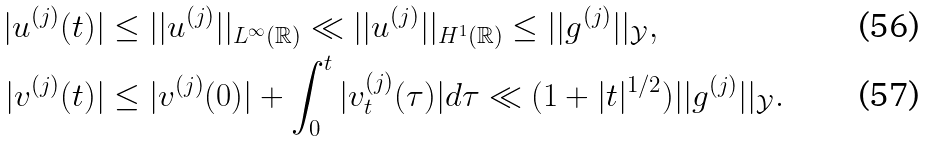Convert formula to latex. <formula><loc_0><loc_0><loc_500><loc_500>| u ^ { ( j ) } ( t ) | & \leq | | u ^ { ( j ) } | | _ { L ^ { \infty } ( \mathbb { R } ) } \ll | | u ^ { ( j ) } | | _ { H ^ { 1 } ( \mathbb { R } ) } \leq | | g ^ { ( j ) } | | _ { \mathcal { Y } } , \\ | v ^ { ( j ) } ( t ) | & \leq | v ^ { ( j ) } ( 0 ) | + \int _ { 0 } ^ { t } | v ^ { ( j ) } _ { t } ( \tau ) | d \tau \ll ( 1 + | t | ^ { 1 / 2 } ) | | g ^ { ( j ) } | | _ { \mathcal { Y } } .</formula> 